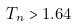Convert formula to latex. <formula><loc_0><loc_0><loc_500><loc_500>T _ { n } > 1 . 6 4</formula> 